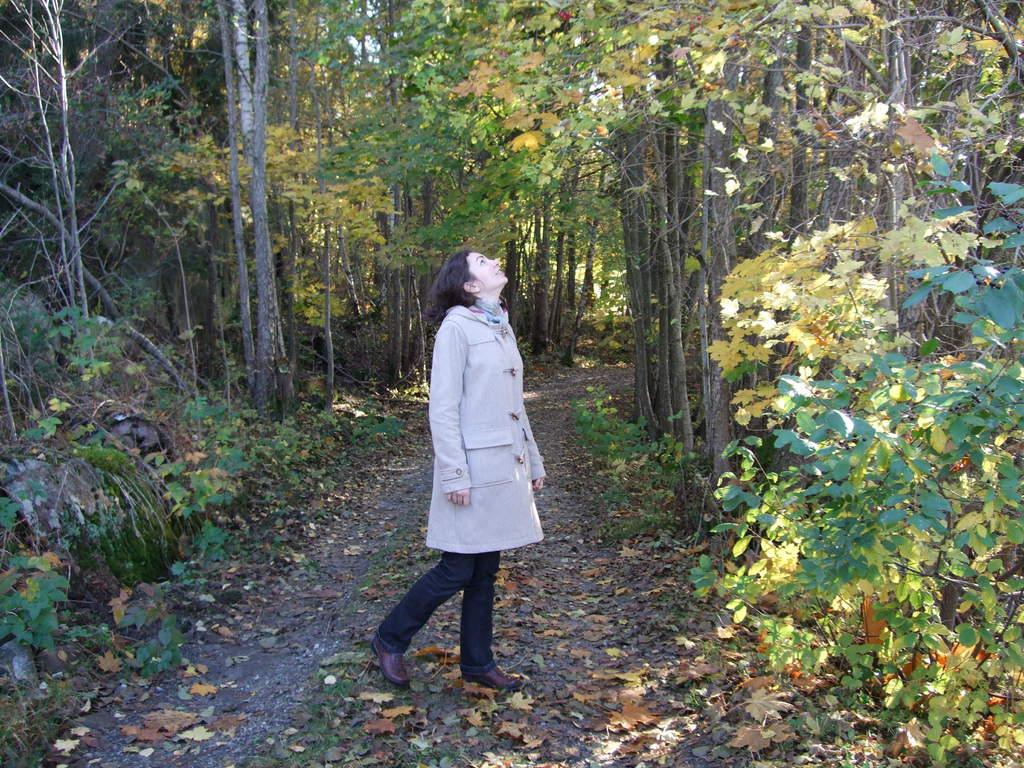Who is the main subject in the image? There is a lady in the center of the image. What can be seen in the background of the image? There are trees in the background of the image. What is covering the ground at the bottom of the image? The ground at the bottom of the image is covered with leaves. How many snails can be seen crawling on the lady's dress in the image? There are no snails visible on the lady's dress in the image. What color are the lady's eyes in the image? The lady's eye color cannot be determined from the image, as her eyes are not visible. 